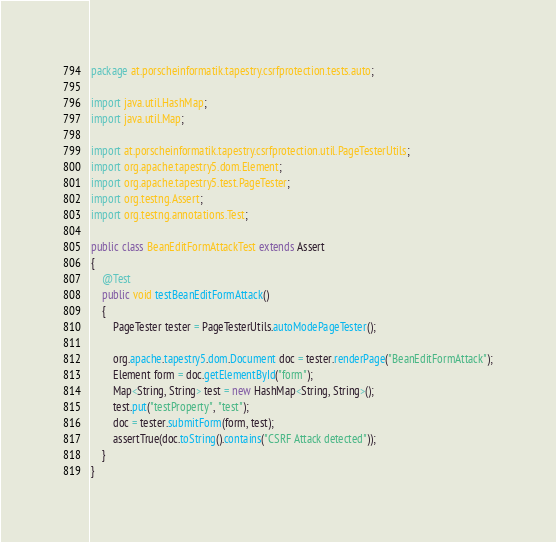Convert code to text. <code><loc_0><loc_0><loc_500><loc_500><_Java_>package at.porscheinformatik.tapestry.csrfprotection.tests.auto;

import java.util.HashMap;
import java.util.Map;

import at.porscheinformatik.tapestry.csrfprotection.util.PageTesterUtils;
import org.apache.tapestry5.dom.Element;
import org.apache.tapestry5.test.PageTester;
import org.testng.Assert;
import org.testng.annotations.Test;

public class BeanEditFormAttackTest extends Assert
{
    @Test
    public void testBeanEditFormAttack()
    {
        PageTester tester = PageTesterUtils.autoModePageTester();

        org.apache.tapestry5.dom.Document doc = tester.renderPage("BeanEditFormAttack");
        Element form = doc.getElementById("form");
        Map<String, String> test = new HashMap<String, String>();
        test.put("testProperty", "test");
        doc = tester.submitForm(form, test);
        assertTrue(doc.toString().contains("CSRF Attack detected"));
    }
}
</code> 